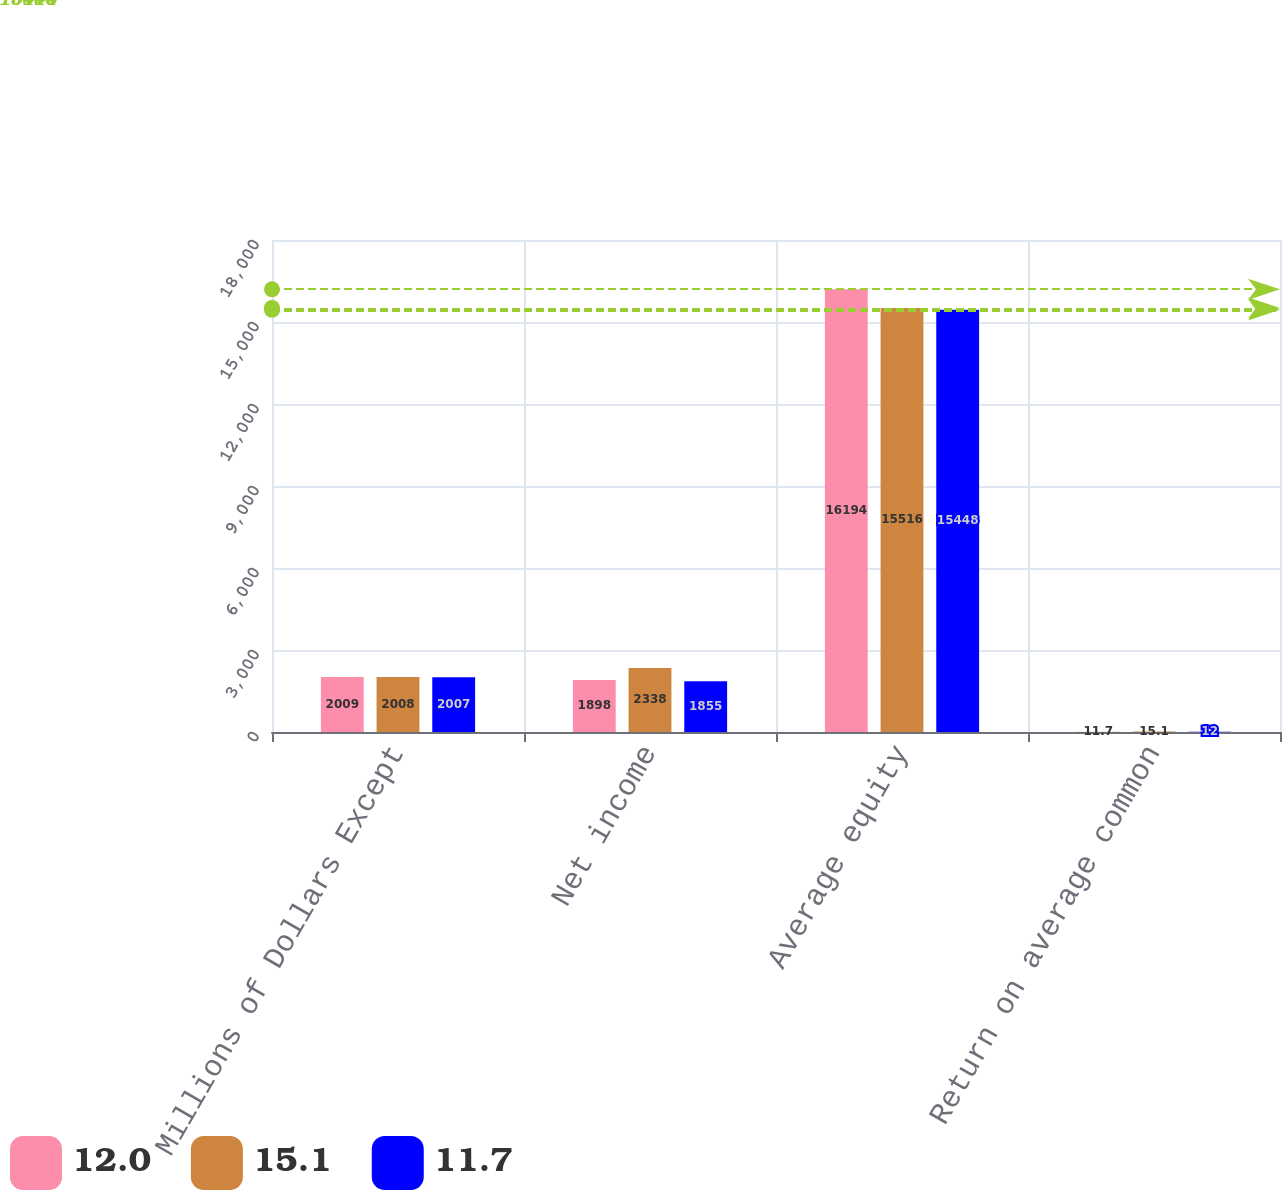Convert chart to OTSL. <chart><loc_0><loc_0><loc_500><loc_500><stacked_bar_chart><ecel><fcel>Millions of Dollars Except<fcel>Net income<fcel>Average equity<fcel>Return on average common<nl><fcel>12<fcel>2009<fcel>1898<fcel>16194<fcel>11.7<nl><fcel>15.1<fcel>2008<fcel>2338<fcel>15516<fcel>15.1<nl><fcel>11.7<fcel>2007<fcel>1855<fcel>15448<fcel>12<nl></chart> 